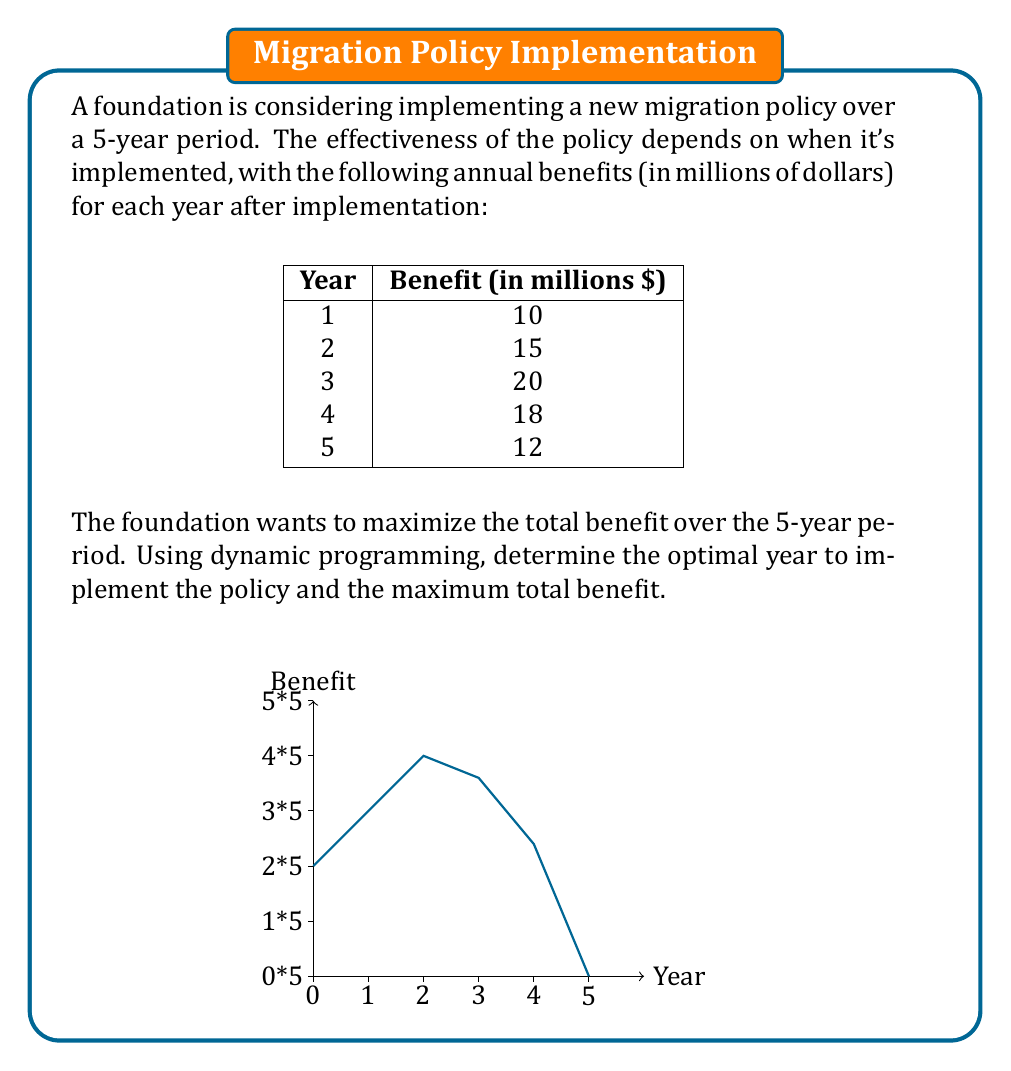Can you solve this math problem? Let's solve this problem using dynamic programming:

1) Define the state and decision variables:
   - State: year $t$ (1 to 5)
   - Decision: implement (1) or wait (0)

2) Define the value function:
   $V(t)$ = maximum benefit from year $t$ to year 5

3) Formulate the Bellman equation:
   $$V(t) = \max\{B(t,5), V(t+1)\}$$
   where $B(t,5)$ is the benefit of implementing in year $t$ until year 5

4) Calculate $B(t,5)$ for each year:
   $B(5,5) = 12$
   $B(4,5) = 18 + 12 = 30$
   $B(3,5) = 20 + 18 + 12 = 50$
   $B(2,5) = 15 + 20 + 18 + 12 = 65$
   $B(1,5) = 10 + 15 + 20 + 18 + 12 = 75$

5) Solve the problem backwards:
   $V(5) = \max\{12, 0\} = 12$
   $V(4) = \max\{30, 12\} = 30$
   $V(3) = \max\{50, 30\} = 50$
   $V(2) = \max\{65, 50\} = 65$
   $V(1) = \max\{75, 65\} = 75$

6) The optimal decision is to implement in year 1, as $V(1) = 75$ million.

Therefore, the optimal year to implement the policy is year 1, and the maximum total benefit is $75 million.
Answer: Year 1; $75 million 